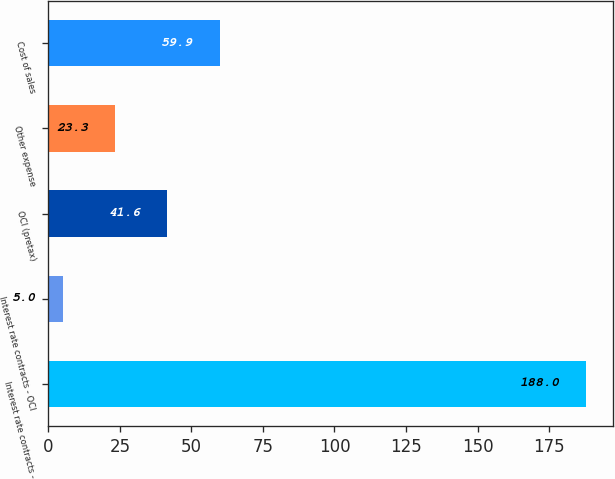Convert chart to OTSL. <chart><loc_0><loc_0><loc_500><loc_500><bar_chart><fcel>Interest rate contracts -<fcel>Interest rate contracts - OCI<fcel>OCI (pretax)<fcel>Other expense<fcel>Cost of sales<nl><fcel>188<fcel>5<fcel>41.6<fcel>23.3<fcel>59.9<nl></chart> 